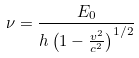<formula> <loc_0><loc_0><loc_500><loc_500>\nu = \frac { E _ { 0 } } { h \left ( 1 - \frac { v ^ { 2 } } { c ^ { 2 } } \right ) ^ { 1 / 2 } }</formula> 